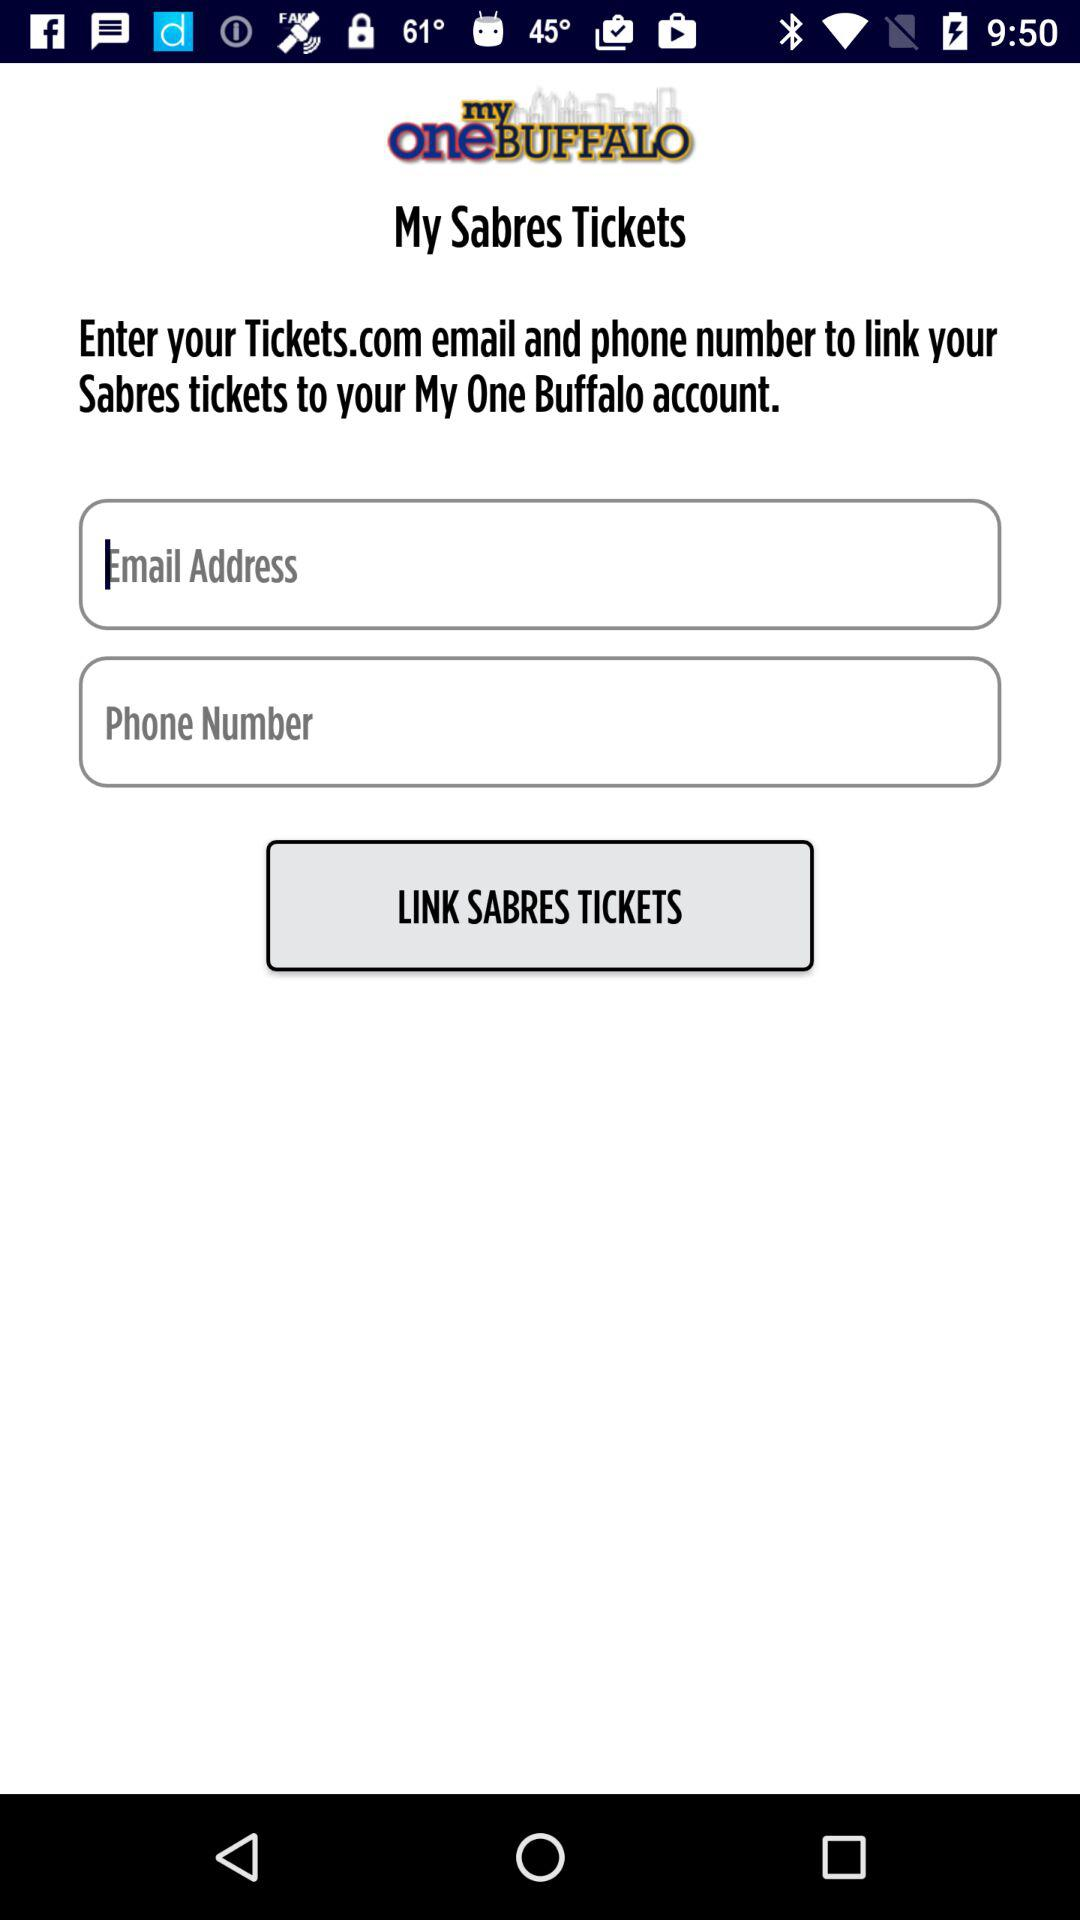Which account can the "Sabres" tickets be linked to? The "Sabres" tickets can be linked to the "My One Buffalo" account. 